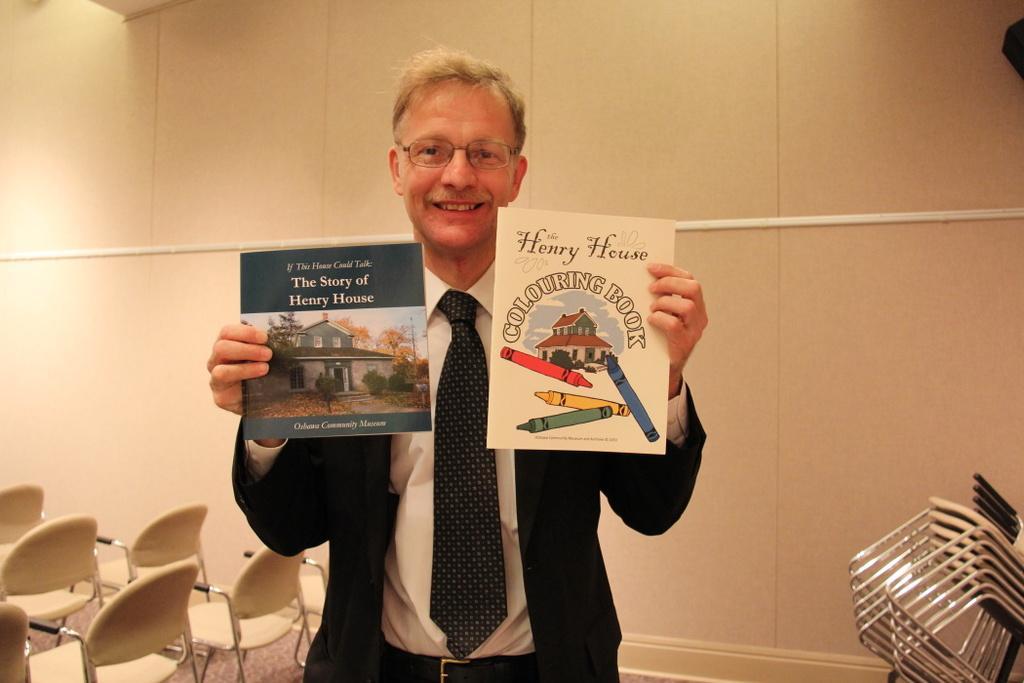In one or two sentences, can you explain what this image depicts? In this image, we can see person in front of the wall. This person is wearing clothes and holding flyers with his hands. There are some chairs in the bottom right of the image. There is an object in the bottom right of the image. 